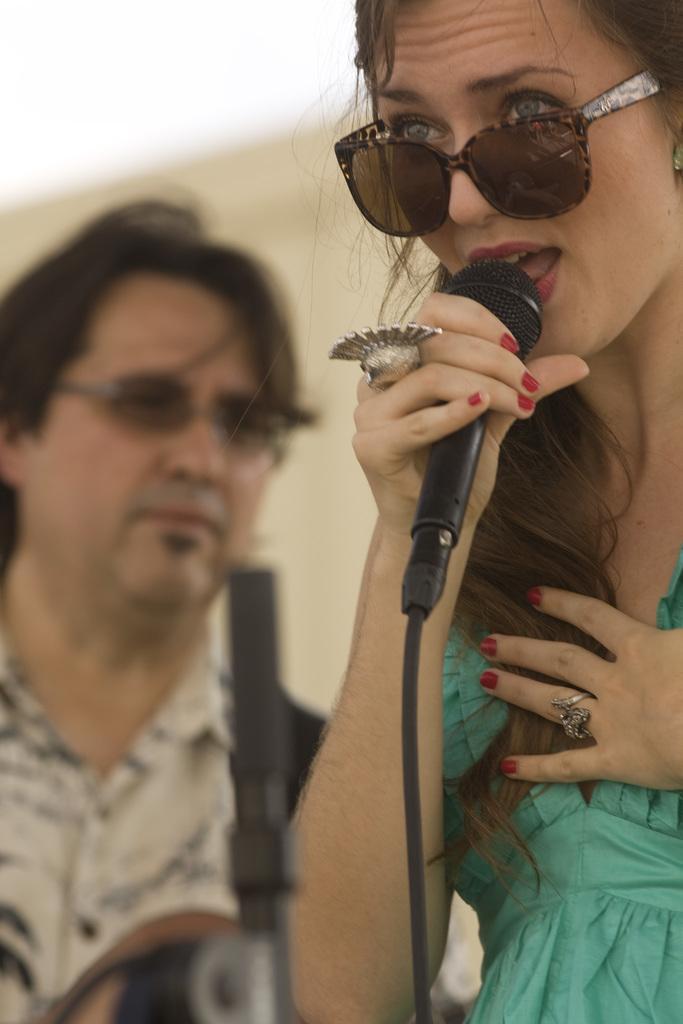Describe this image in one or two sentences. In this picture we can see a woman who is holding a mike with her hand. She has goggles. Here we can see a man. 